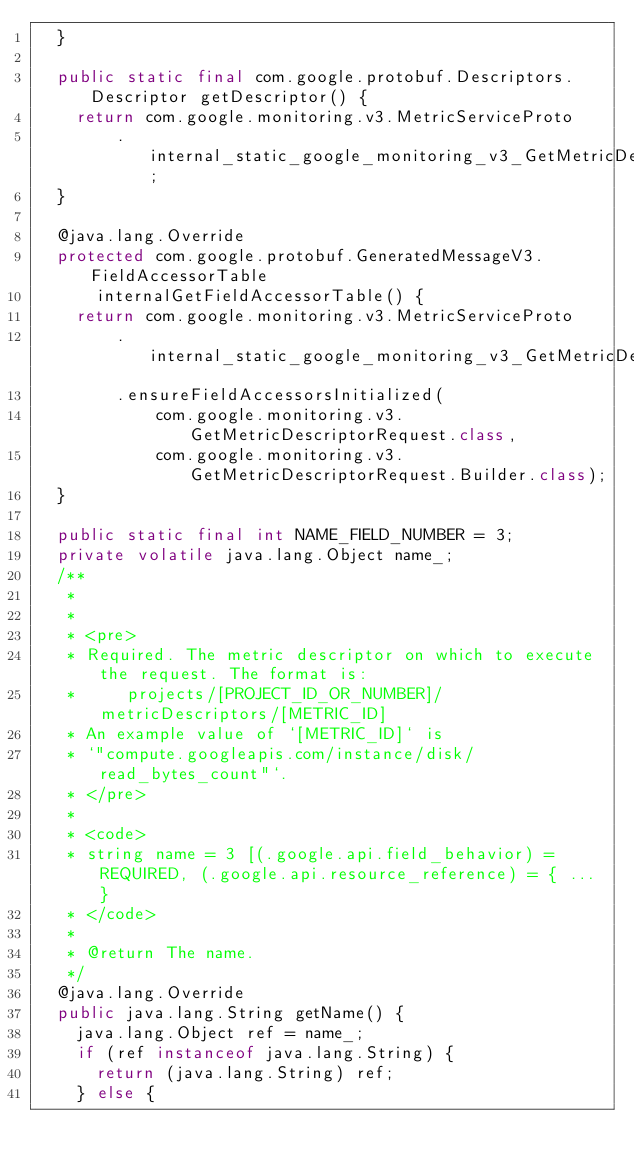Convert code to text. <code><loc_0><loc_0><loc_500><loc_500><_Java_>  }

  public static final com.google.protobuf.Descriptors.Descriptor getDescriptor() {
    return com.google.monitoring.v3.MetricServiceProto
        .internal_static_google_monitoring_v3_GetMetricDescriptorRequest_descriptor;
  }

  @java.lang.Override
  protected com.google.protobuf.GeneratedMessageV3.FieldAccessorTable
      internalGetFieldAccessorTable() {
    return com.google.monitoring.v3.MetricServiceProto
        .internal_static_google_monitoring_v3_GetMetricDescriptorRequest_fieldAccessorTable
        .ensureFieldAccessorsInitialized(
            com.google.monitoring.v3.GetMetricDescriptorRequest.class,
            com.google.monitoring.v3.GetMetricDescriptorRequest.Builder.class);
  }

  public static final int NAME_FIELD_NUMBER = 3;
  private volatile java.lang.Object name_;
  /**
   *
   *
   * <pre>
   * Required. The metric descriptor on which to execute the request. The format is:
   *     projects/[PROJECT_ID_OR_NUMBER]/metricDescriptors/[METRIC_ID]
   * An example value of `[METRIC_ID]` is
   * `"compute.googleapis.com/instance/disk/read_bytes_count"`.
   * </pre>
   *
   * <code>
   * string name = 3 [(.google.api.field_behavior) = REQUIRED, (.google.api.resource_reference) = { ... }
   * </code>
   *
   * @return The name.
   */
  @java.lang.Override
  public java.lang.String getName() {
    java.lang.Object ref = name_;
    if (ref instanceof java.lang.String) {
      return (java.lang.String) ref;
    } else {</code> 